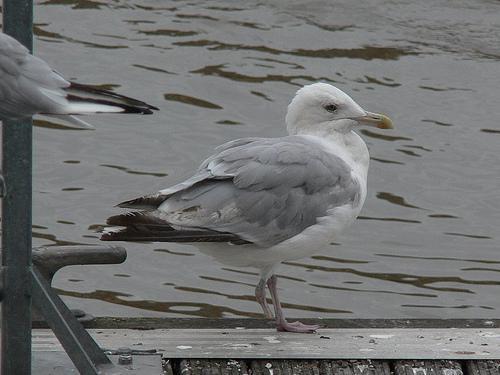How many pelicans can be seen?
Give a very brief answer. 1. 